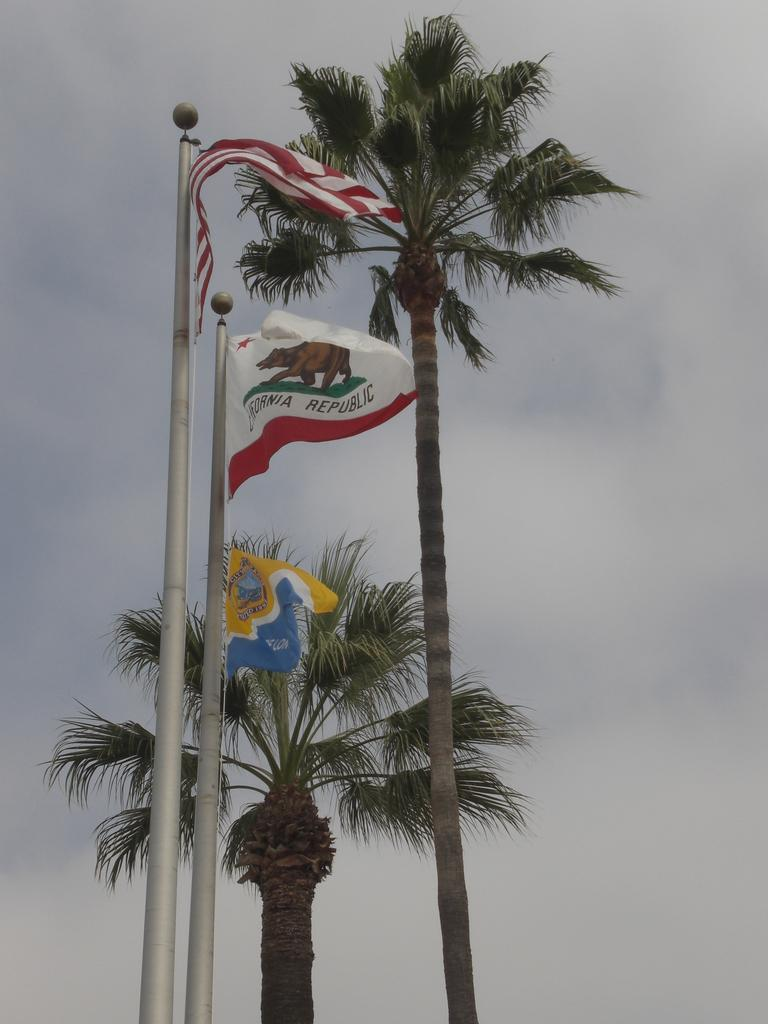What type of natural elements can be seen in the image? There are trees in the image. What man-made structures are present in the image? There are flag poles in the image. How many flags are visible on the flag poles? There are three flags on the flag poles. What is the condition of the sky in the image? The sky is cloudy in the image. What type of book is being read by the sun in the image? There is no sun or book present in the image. What color is the gold object that is being held by the trees? There is no gold object present in the image. 